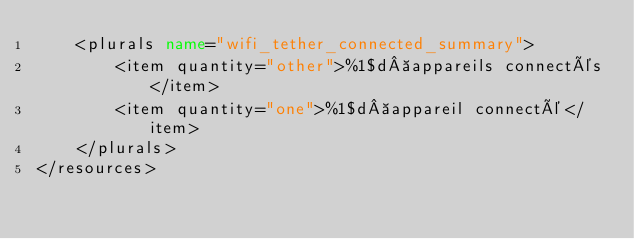Convert code to text. <code><loc_0><loc_0><loc_500><loc_500><_XML_>    <plurals name="wifi_tether_connected_summary">
        <item quantity="other">%1$d appareils connectés</item>
        <item quantity="one">%1$d appareil connecté</item>
    </plurals>
</resources>
</code> 